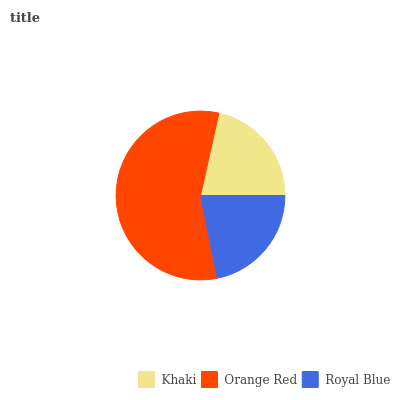Is Khaki the minimum?
Answer yes or no. Yes. Is Orange Red the maximum?
Answer yes or no. Yes. Is Royal Blue the minimum?
Answer yes or no. No. Is Royal Blue the maximum?
Answer yes or no. No. Is Orange Red greater than Royal Blue?
Answer yes or no. Yes. Is Royal Blue less than Orange Red?
Answer yes or no. Yes. Is Royal Blue greater than Orange Red?
Answer yes or no. No. Is Orange Red less than Royal Blue?
Answer yes or no. No. Is Royal Blue the high median?
Answer yes or no. Yes. Is Royal Blue the low median?
Answer yes or no. Yes. Is Orange Red the high median?
Answer yes or no. No. Is Orange Red the low median?
Answer yes or no. No. 